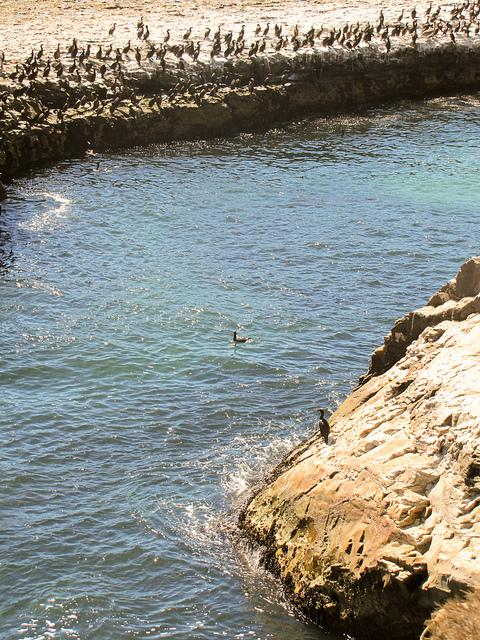What surface are all the birds standing on next to the big river? Please explain your reasoning. stone. There is a stone surface. 